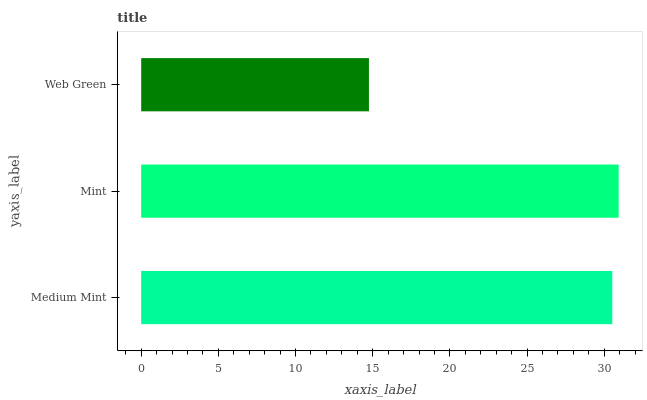Is Web Green the minimum?
Answer yes or no. Yes. Is Mint the maximum?
Answer yes or no. Yes. Is Mint the minimum?
Answer yes or no. No. Is Web Green the maximum?
Answer yes or no. No. Is Mint greater than Web Green?
Answer yes or no. Yes. Is Web Green less than Mint?
Answer yes or no. Yes. Is Web Green greater than Mint?
Answer yes or no. No. Is Mint less than Web Green?
Answer yes or no. No. Is Medium Mint the high median?
Answer yes or no. Yes. Is Medium Mint the low median?
Answer yes or no. Yes. Is Mint the high median?
Answer yes or no. No. Is Mint the low median?
Answer yes or no. No. 